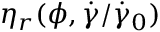Convert formula to latex. <formula><loc_0><loc_0><loc_500><loc_500>\eta _ { r } ( \phi , \dot { \gamma } / \dot { \gamma } _ { 0 } )</formula> 